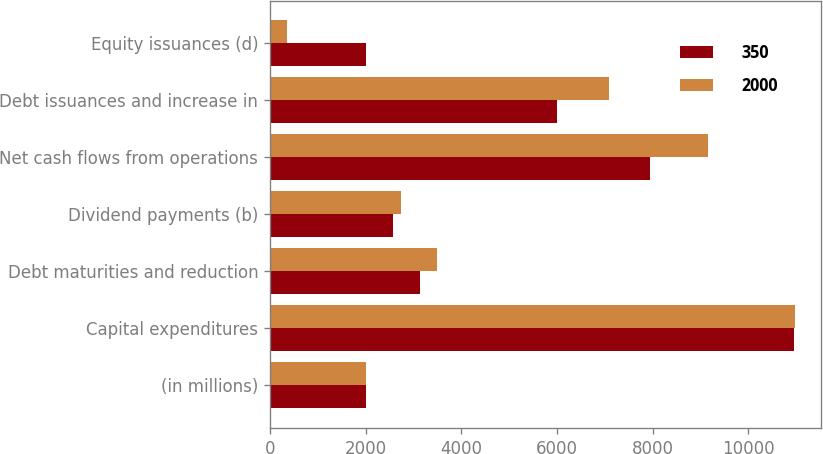Convert chart. <chart><loc_0><loc_0><loc_500><loc_500><stacked_bar_chart><ecel><fcel>(in millions)<fcel>Capital expenditures<fcel>Debt maturities and reduction<fcel>Dividend payments (b)<fcel>Net cash flows from operations<fcel>Debt issuances and increase in<fcel>Equity issuances (d)<nl><fcel>350<fcel>2018<fcel>10950<fcel>3135<fcel>2575<fcel>7945<fcel>6000<fcel>2000<nl><fcel>2000<fcel>2019<fcel>10975<fcel>3500<fcel>2750<fcel>9150<fcel>7100<fcel>350<nl></chart> 